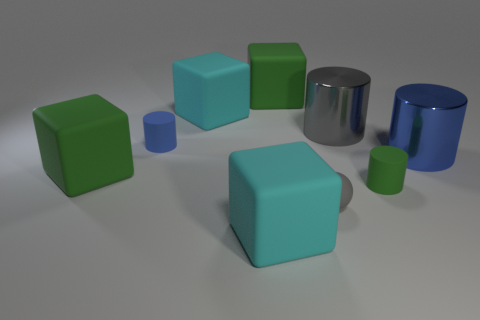What number of cubes are either gray metal objects or blue metal objects?
Your response must be concise. 0. There is a thing that is on the left side of the tiny blue object; is its size the same as the blue metal thing that is behind the small gray ball?
Keep it short and to the point. Yes. What is the material of the large cylinder that is in front of the tiny cylinder that is on the left side of the large gray shiny cylinder?
Your answer should be very brief. Metal. Is the number of cylinders that are to the right of the tiny gray sphere less than the number of gray balls?
Your answer should be compact. No. What shape is the gray thing that is the same material as the big blue object?
Offer a terse response. Cylinder. What number of other objects are the same shape as the blue metallic thing?
Offer a terse response. 3. What number of cyan objects are either rubber cubes or rubber balls?
Provide a succinct answer. 2. Does the large gray metal thing have the same shape as the tiny blue thing?
Provide a succinct answer. Yes. Is there a tiny blue matte object that is in front of the large green rubber object in front of the small blue cylinder?
Your answer should be very brief. No. Are there the same number of gray metallic objects in front of the green cylinder and small red rubber balls?
Provide a succinct answer. Yes. 